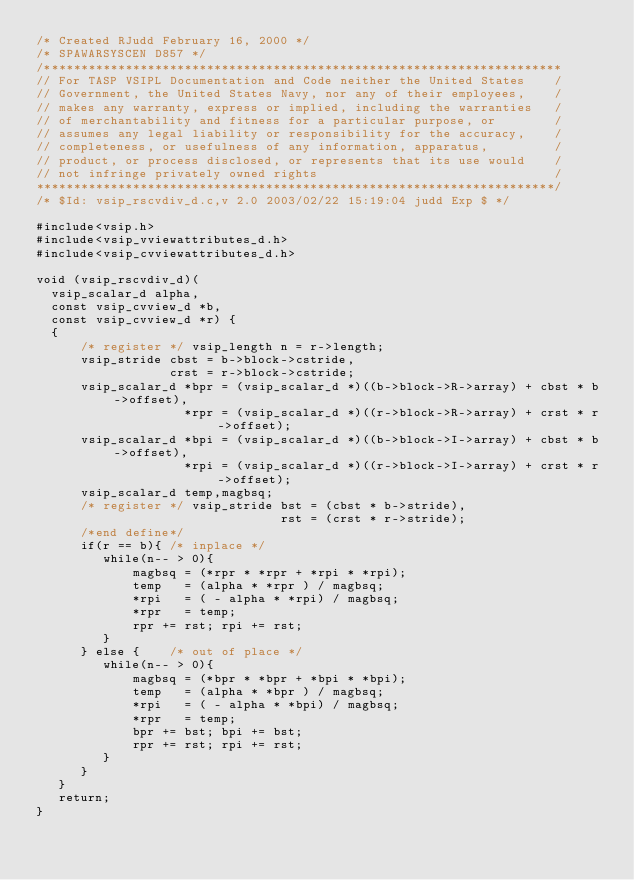<code> <loc_0><loc_0><loc_500><loc_500><_C_>/* Created RJudd February 16, 2000 */
/* SPAWARSYSCEN D857 */
/**********************************************************************
// For TASP VSIPL Documentation and Code neither the United States    /
// Government, the United States Navy, nor any of their employees,    /
// makes any warranty, express or implied, including the warranties   /
// of merchantability and fitness for a particular purpose, or        /
// assumes any legal liability or responsibility for the accuracy,    /
// completeness, or usefulness of any information, apparatus,         /
// product, or process disclosed, or represents that its use would    /
// not infringe privately owned rights                                /
**********************************************************************/
/* $Id: vsip_rscvdiv_d.c,v 2.0 2003/02/22 15:19:04 judd Exp $ */

#include<vsip.h>
#include<vsip_vviewattributes_d.h>
#include<vsip_cvviewattributes_d.h>

void (vsip_rscvdiv_d)(
  vsip_scalar_d alpha,
  const vsip_cvview_d *b,
  const vsip_cvview_d *r) {
  { 
      /* register */ vsip_length n = r->length;
      vsip_stride cbst = b->block->cstride,
                  crst = r->block->cstride;
      vsip_scalar_d *bpr = (vsip_scalar_d *)((b->block->R->array) + cbst * b->offset),
                    *rpr = (vsip_scalar_d *)((r->block->R->array) + crst * r->offset);
      vsip_scalar_d *bpi = (vsip_scalar_d *)((b->block->I->array) + cbst * b->offset),
                    *rpi = (vsip_scalar_d *)((r->block->I->array) + crst * r->offset);
      vsip_scalar_d temp,magbsq;
      /* register */ vsip_stride bst = (cbst * b->stride),
                                 rst = (crst * r->stride);
      /*end define*/
      if(r == b){ /* inplace */
         while(n-- > 0){
             magbsq = (*rpr * *rpr + *rpi * *rpi);
             temp   = (alpha * *rpr ) / magbsq;
             *rpi   = ( - alpha * *rpi) / magbsq;
             *rpr   = temp;
             rpr += rst; rpi += rst;
         }
      } else {    /* out of place */
         while(n-- > 0){
             magbsq = (*bpr * *bpr + *bpi * *bpi);
             temp   = (alpha * *bpr ) / magbsq;
             *rpi   = ( - alpha * *bpi) / magbsq;
             *rpr   = temp;
             bpr += bst; bpi += bst;
             rpr += rst; rpi += rst;
         }
      }
   }
   return;
}
</code> 